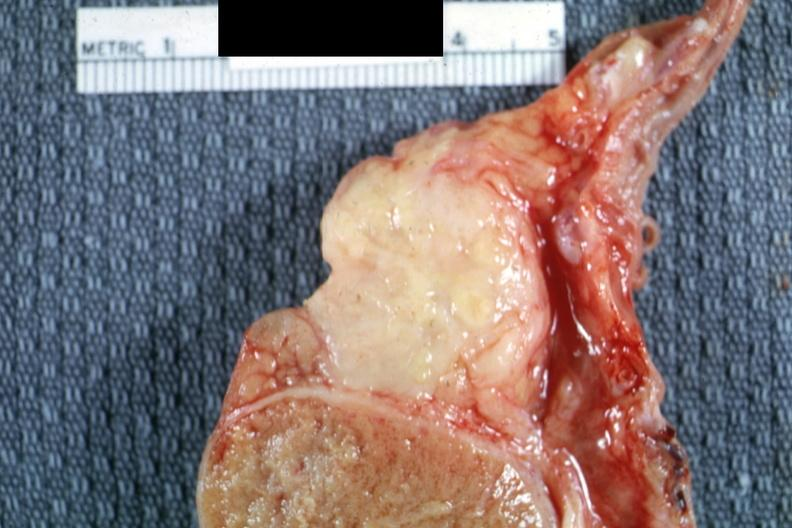does this image show fibrocaseous mass of tissue?
Answer the question using a single word or phrase. Yes 